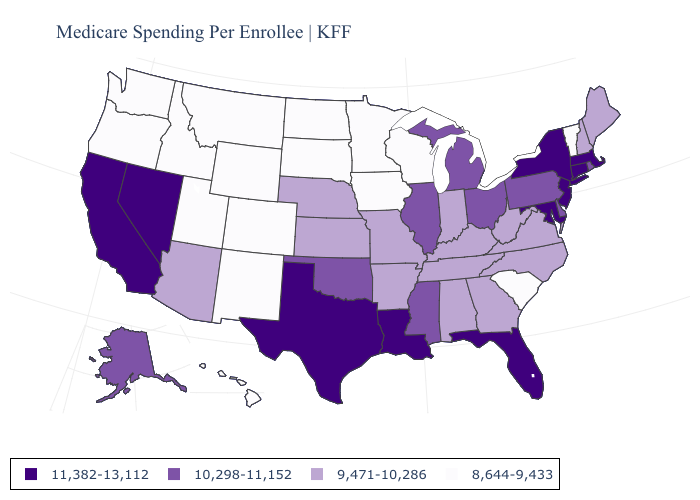What is the value of Hawaii?
Give a very brief answer. 8,644-9,433. Among the states that border Vermont , which have the lowest value?
Write a very short answer. New Hampshire. Name the states that have a value in the range 10,298-11,152?
Quick response, please. Alaska, Delaware, Illinois, Michigan, Mississippi, Ohio, Oklahoma, Pennsylvania, Rhode Island. What is the value of Michigan?
Quick response, please. 10,298-11,152. Name the states that have a value in the range 9,471-10,286?
Be succinct. Alabama, Arizona, Arkansas, Georgia, Indiana, Kansas, Kentucky, Maine, Missouri, Nebraska, New Hampshire, North Carolina, Tennessee, Virginia, West Virginia. What is the value of Texas?
Be succinct. 11,382-13,112. Among the states that border Colorado , does Wyoming have the highest value?
Be succinct. No. Does New Hampshire have the highest value in the USA?
Concise answer only. No. Does Pennsylvania have the same value as Michigan?
Give a very brief answer. Yes. How many symbols are there in the legend?
Be succinct. 4. What is the value of Pennsylvania?
Answer briefly. 10,298-11,152. Does Maryland have the highest value in the USA?
Concise answer only. Yes. Name the states that have a value in the range 9,471-10,286?
Concise answer only. Alabama, Arizona, Arkansas, Georgia, Indiana, Kansas, Kentucky, Maine, Missouri, Nebraska, New Hampshire, North Carolina, Tennessee, Virginia, West Virginia. Name the states that have a value in the range 9,471-10,286?
Concise answer only. Alabama, Arizona, Arkansas, Georgia, Indiana, Kansas, Kentucky, Maine, Missouri, Nebraska, New Hampshire, North Carolina, Tennessee, Virginia, West Virginia. What is the highest value in the West ?
Keep it brief. 11,382-13,112. 